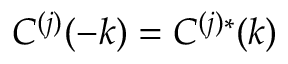<formula> <loc_0><loc_0><loc_500><loc_500>C ^ { ( j ) } ( - k ) = C ^ { ( j ) * } ( k )</formula> 